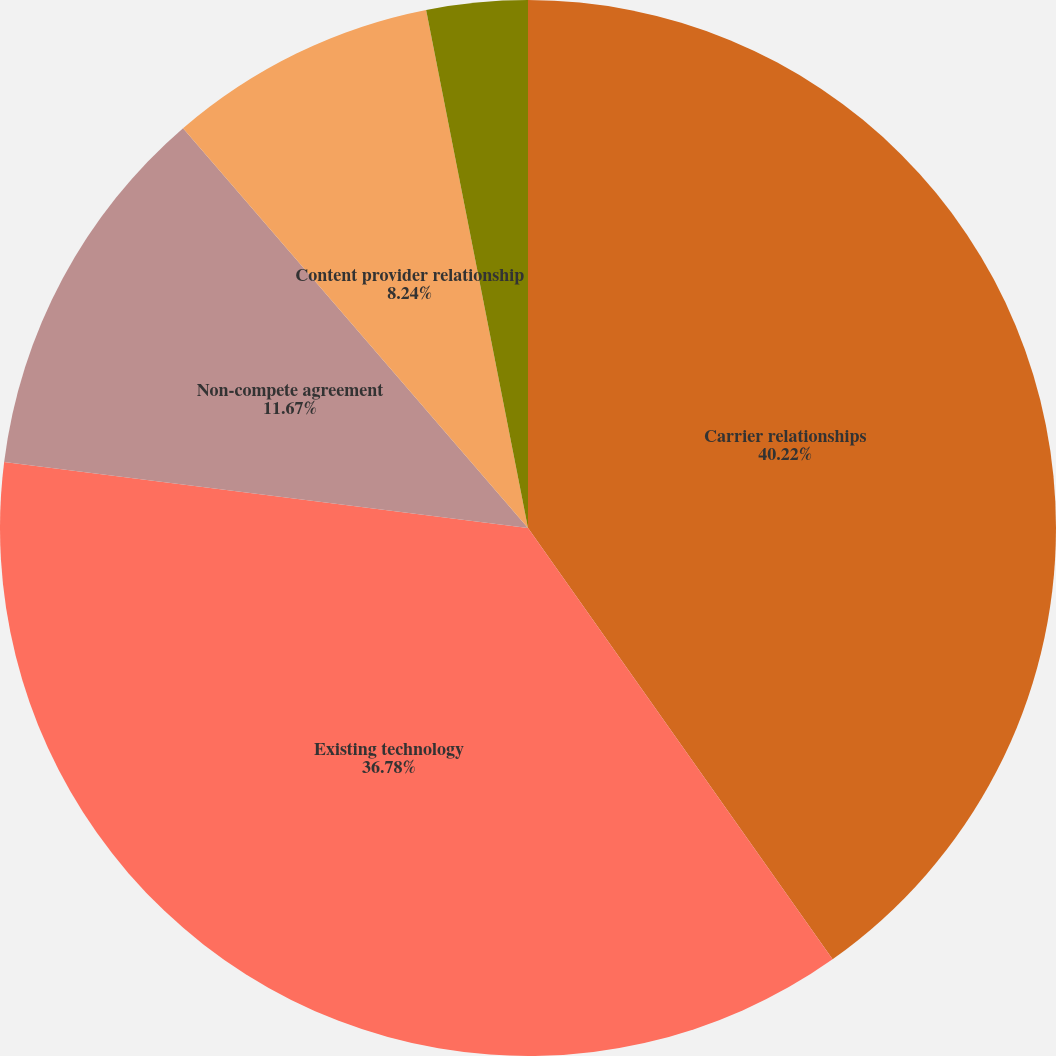Convert chart. <chart><loc_0><loc_0><loc_500><loc_500><pie_chart><fcel>Carrier relationships<fcel>Existing technology<fcel>Non-compete agreement<fcel>Content provider relationship<fcel>Trade name<nl><fcel>40.21%<fcel>36.78%<fcel>11.67%<fcel>8.24%<fcel>3.09%<nl></chart> 